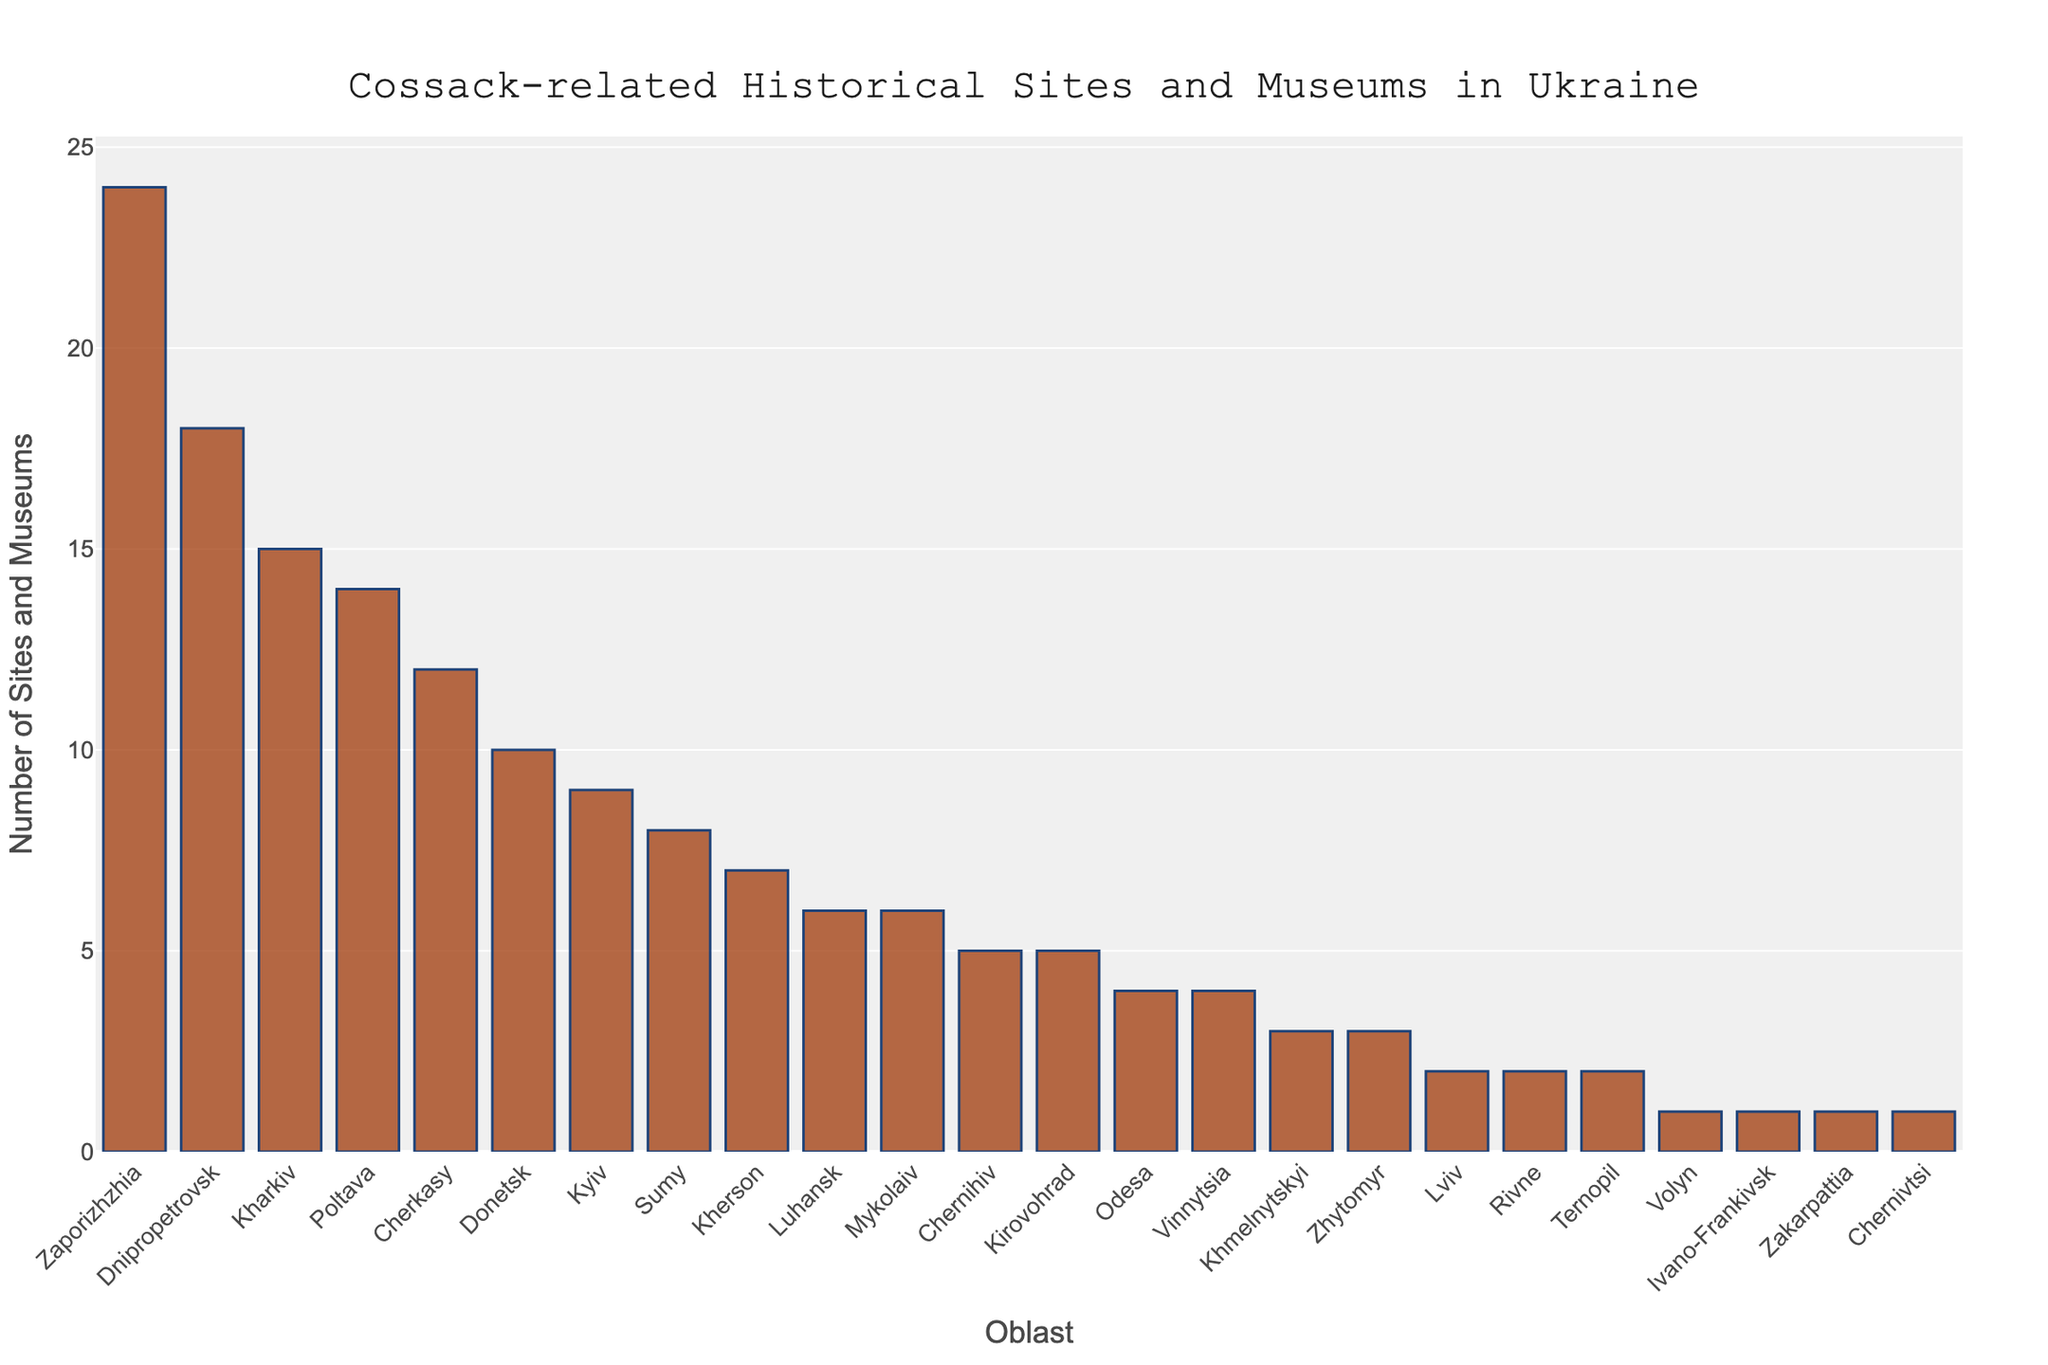What's the oblast with the highest number of Cossack-related sites and museums? The oblast with the tallest bar represents the highest number of Cossack-related sites and museums. Zaporizhzhia has the highest count with 24 sites and museums.
Answer: Zaporizhzhia Which oblast has more Cossack-related sites and museums, Kyiv or Donetsk? To compare, look at the heights of the bars for Kyiv and Donetsk. Donetsk has a higher bar with 10 sites and museums, while Kyiv has 9.
Answer: Donetsk How many more Cossack-related sites and museums does Zaporizhzhia have compared to Mykolaiv? Calculate the difference between the counts for Zaporizhzhia (24) and Mykolaiv (6). The difference is 24 - 6 = 18.
Answer: 18 What are the top three oblasts in terms of the number of Cossack-related sites and museums? Identify the three tallest bars, which correspond to Zaporizhzhia, Dnipropetrovsk, and Kharkiv with 24, 18, and 15 sites respectively.
Answer: Zaporizhzhia, Dnipropetrovsk, Kharkiv Which oblasts have exactly 6 Cossack-related sites and museums? Find the bars that correspond to 6 in height. Luhansk and Mykolaiv each have 6 sites and museums.
Answer: Luhansk, Mykolaiv How much fewer Cossack-related sites and museums does Ivano-Frankivsk have compared to Poltava? Subtract the number for Ivano-Frankivsk (1) from Poltava (14). The difference is 14 - 1 = 13.
Answer: 13 What’s the average number of Cossack-related sites and museums in the top five oblasts? Calculate the sum for the top five oblasts and then divide by 5. (24 + 18 + 15 + 14 + 12) / 5 = 16.6.
Answer: 16.6 Is the number of Cossack-related sites and museums in Sumy more or less than half of that in Zaporizhzhia? Compare the number for Sumy (8) to half of Zaporizhzhia's count (24 / 2 = 12). Sumy has fewer.
Answer: Less Which oblast has the lowest number of Cossack-related sites and museums, and how many are there? Identify the shortest bars which are for Ivano-Frankivsk, Zakarpattia, and Chernivtsi, each with 1 site and museum.
Answer: Ivano-Frankivsk, Zakarpattia, Chernivtsi What is the combined total of Cossack-related sites and museums for the oblasts from Luhansk to Zakarpattia? Sum the numbers from Luhansk (6) to Zakarpattia (1). 6 + 6 + 5 + 5 + 4 + 4 + 3 + 3 + 2 + 2 + 2 + 1 + 1 + 1 = 47.
Answer: 47 